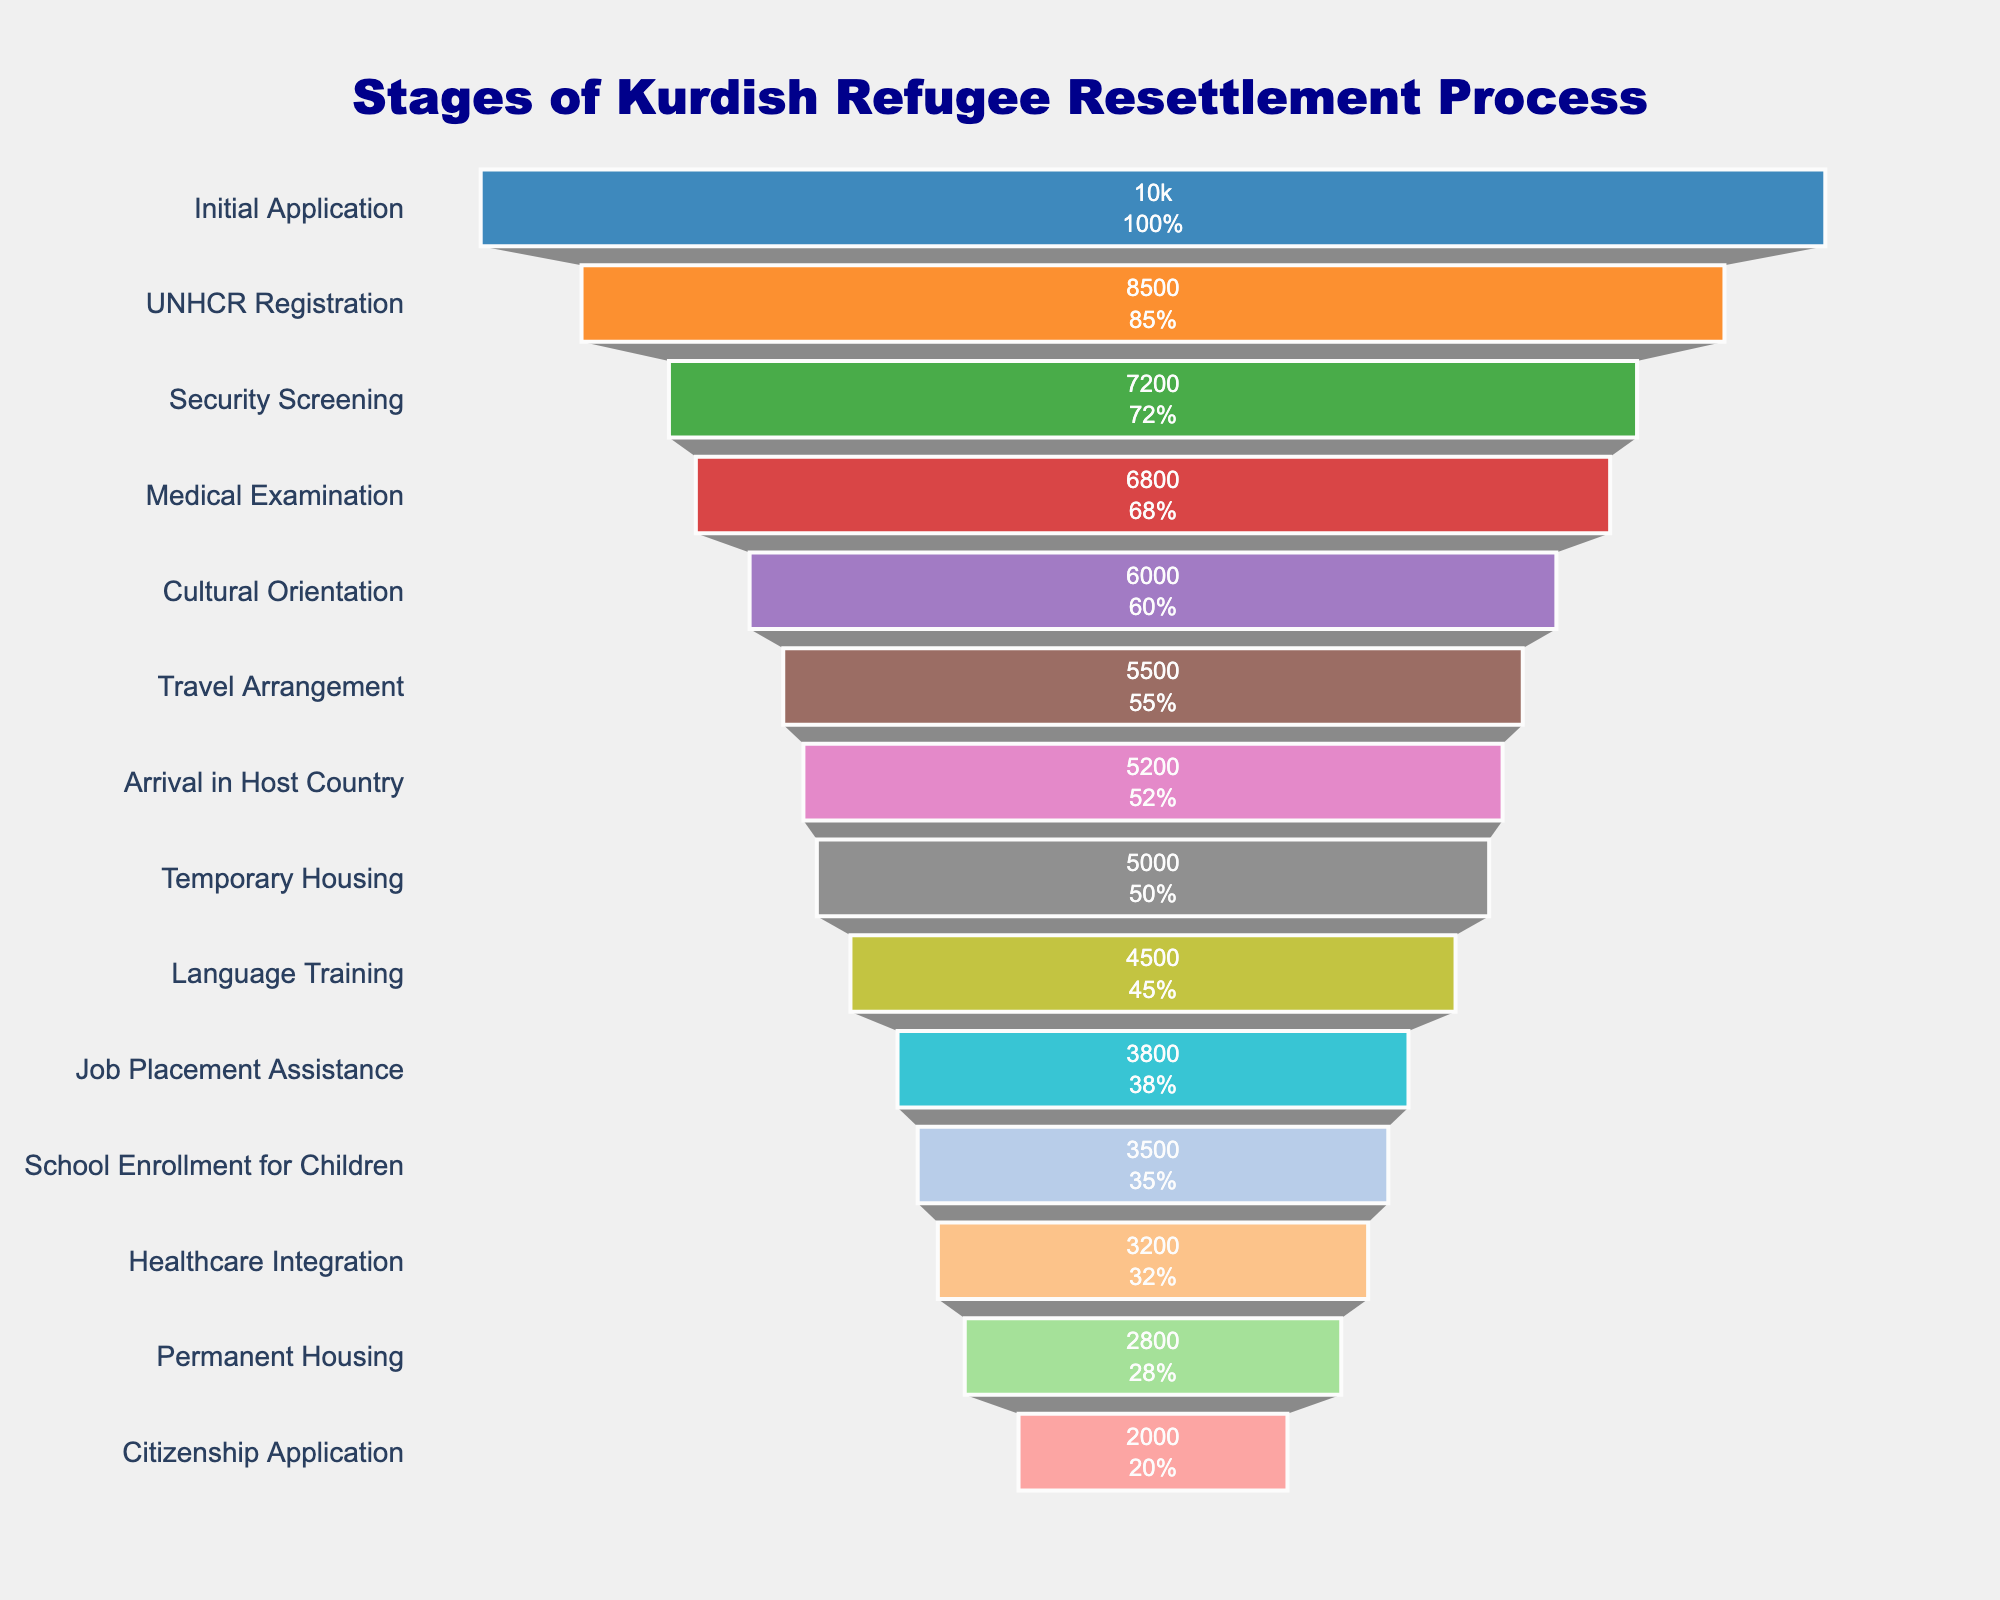What is the title of the funnel chart? The title is displayed at the top center of the chart and reads "Stages of Kurdish Refugee Resettlement Process."
Answer: Stages of Kurdish Refugee Resettlement Process How many stages are shown in the resettlement process? Each stage corresponds to one horizontal segment in the funnel. Counting all segments shows there are 14 stages.
Answer: 14 Which stage has the highest number of Kurdish refugees? The stage with the largest horizontal bar at the top of the chart represents the highest number of Kurdish refugees, which is the "Initial Application" stage with 10,000 refugees.
Answer: Initial Application How many Kurdish refugees reach the stage of School Enrollment for Children? By locating the corresponding horizontal segment labeled "School Enrollment for Children," we see there are 3,500 refugees at this stage.
Answer: 3,500 By how much does the number of Kurdish refugees decrease from the stage of UNHCR Registration to the stage of Language Training? The number of refugees at UNHCR Registration is 8,500, and at Language Training is 4,500. The decrease is calculated as 8,500 - 4,500.
Answer: 4,000 What percentage of the initial applicants reach the final stage of Citizenship Application? The number of refugees at the "Citizenship Application" stage is 2,000 out of the initial 10,000 applicants. The percentage is calculated as (2,000 / 10,000) * 100.
Answer: 20% Between which two consecutive stages is the largest drop in the number of refugees? By observing the width of the bars, the largest drop appears to be between "Cultural Orientation" (6,000) and "Travel Arrangement" (5,500). The drop is 6,000 - 5,500.
Answer: Cultural Orientation to Travel Arrangement What is the difference in the number of refugees between the stages of Medical Examination and Permanent Housing? The number of refugees at Medical Examination is 6,800, and at Permanent Housing is 2,800. The difference is calculated as 6,800 - 2,800.
Answer: 4,000 How many Kurdish refugees are lost between the stage of Arrival in Host Country and the stage of Job Placement Assistance? The number of refugees in the stage of "Arrival in Host Country" is 5,200, and at "Job Placement Assistance" it is 3,800. The loss is computed as 5,200 - 3,800.
Answer: 1,400 What is the average number of Kurdish refugees across all stages listed in the process? Summing the number of refugees for all stages and dividing by the number of stages: (10,000 + 8,500 + 7,200 + 6,800 + 6,000 + 5,500 + 5,200 + 5,000 + 4,500 + 3,800 + 3,500 + 3,200 + 2,800 + 2,000) / 14.
Answer: 5,107 